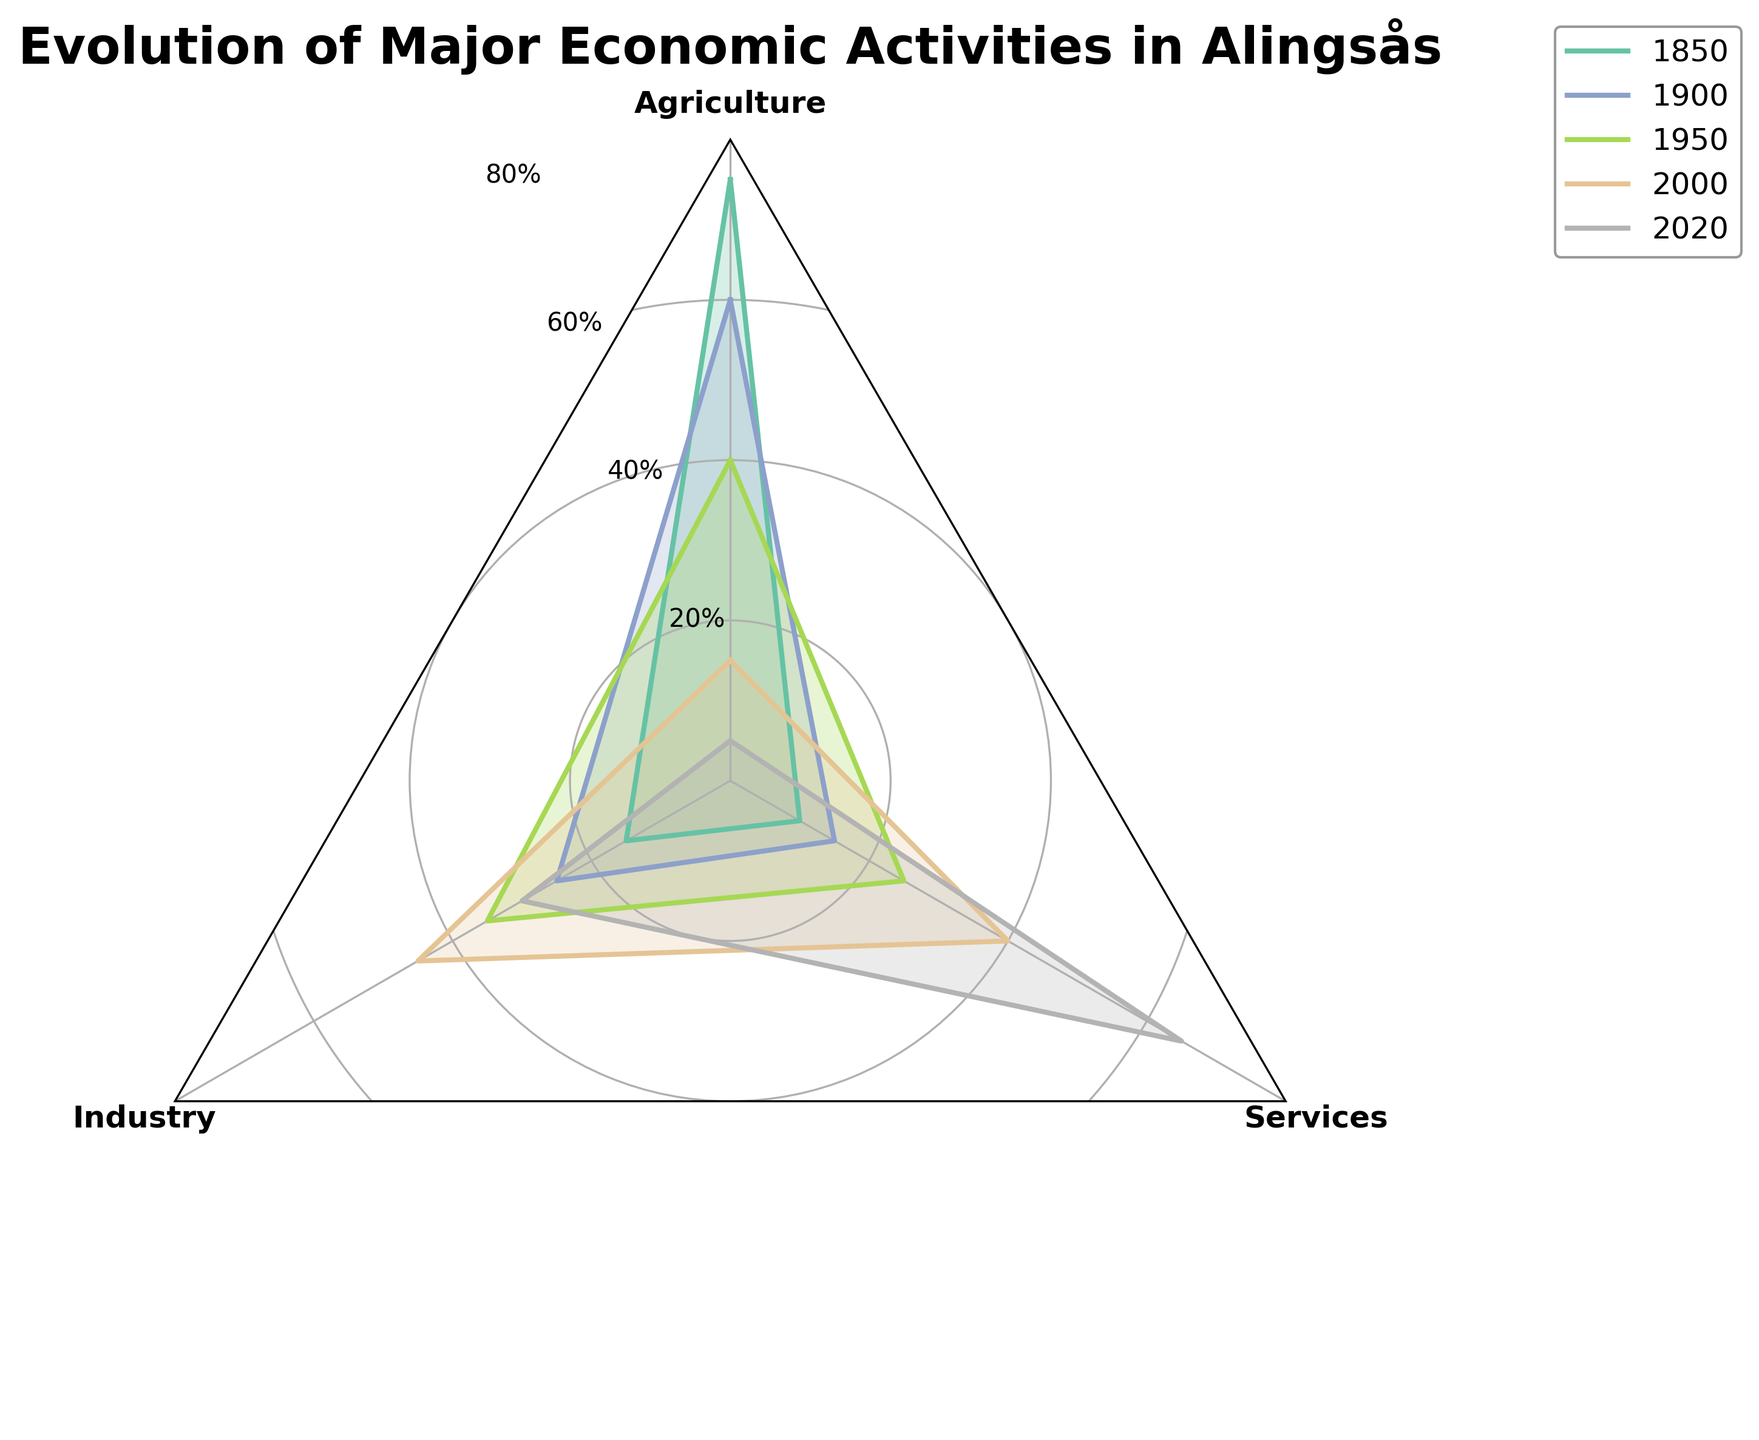What is the dominant economic activity in Alingsås for the year 2020? From the radar chart, observe the three economic activities—Agriculture, Industry, Services—in 2020. The Services sector reaches the highest value, indicating it is the dominant activity.
Answer: Services How has the Agriculture sector evolved from 1850 to 2020? Trace the line representing Agriculture across different time points from 1850 to 2020. Notice a consistent decrease in its percentage, starting from 75% in 1850 to just 5% in 2020.
Answer: It has significantly decreased What's the average percentage of Industry activities over the given periods? Add the percentages of Industry for each time period: (15 + 25 + 35 + 45 + 30) = 150. Then, divide by the number of periods (5): 150 / 5 = 30%.
Answer: 30% In which year did the Industry sector peak? Examine the line for Industry across all years. The highest point on the radar chart for Industry is 45% in the year 2000.
Answer: 2000 Which economic activity had the largest increase between 1850 and 2020? Calculate the increase for each sector over the period: 
Agriculture: 75% - 5% = 70% decrease, 
Industry: 30% - 15% = 15% increase, 
Services: 65% - 10% = 55% increase. 
The Services sector has the largest increase.
Answer: Services Was the Industry sector ever the dominant economic activity in any of the time periods? Check if, in any time period, the Industry's percentage exceeds that of both Agriculture and Services. In 2000, Industry (45%) is higher than Agriculture (15%) and Services (40%), making it the dominant activity then.
Answer: Yes, in 2000 By how much did the Services sector grow from 1900 to 2000? Subtract the Services value in 1900 from that in 2000: 40% - 15% = 25%.
Answer: 25% Compare the Agriculture and Industry sectors in 1950. Which was more prominent and by how much? Look at the percentages of Agriculture (40%) and Industry (35%) in 1950. Agriculture is more prominent; subtract Industry's value from Agriculture's: 40% - 35% = 5%.
Answer: Agriculture, by 5% What's the sum of the percentages for all economic activities in 2020? Add the percentages of all activities in 2020: 5% (Agriculture) + 30% (Industry) + 65% (Services) = 100%.
Answer: 100% Which sector had the smallest fluctuation over the periods observed? Determine the range (max - min values) for each sector: 
Agriculture: 75% - 5% = 70%, 
Industry: 45% - 15% = 30%, 
Services: 65% - 10% = 55%. 
The Industry sector has the smallest fluctuation.
Answer: Industry 